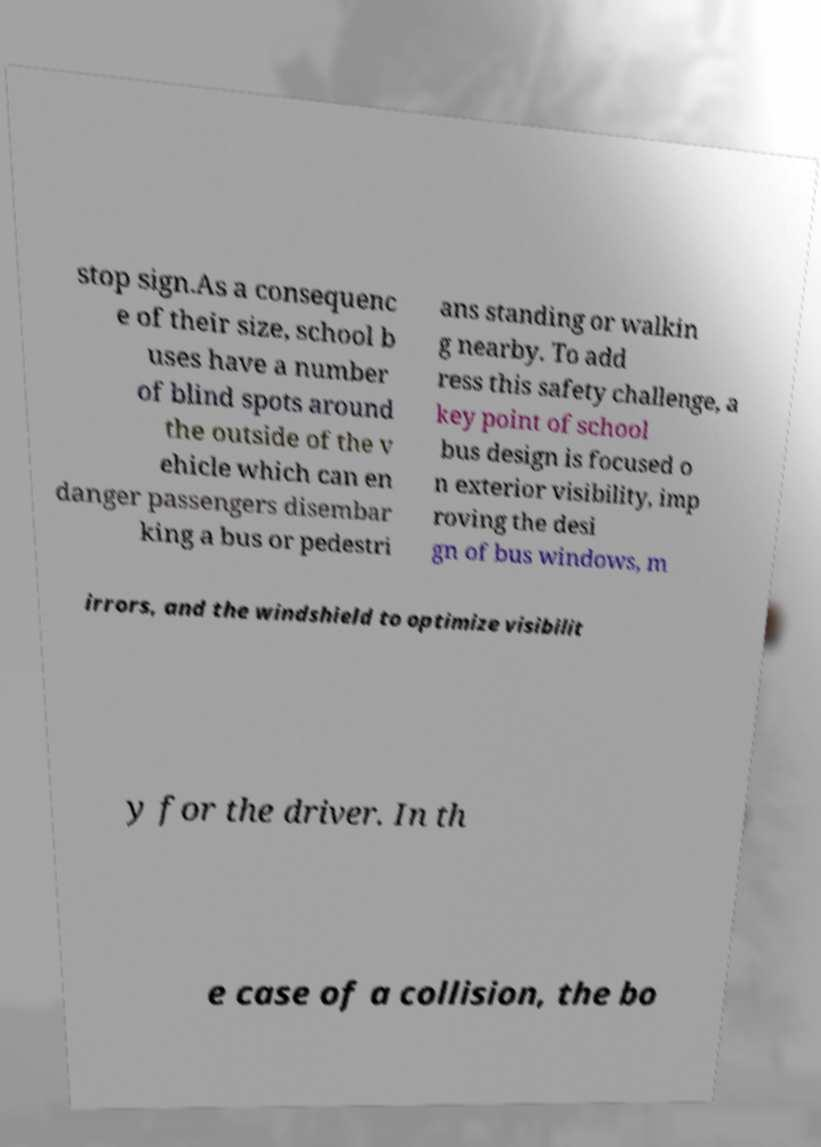I need the written content from this picture converted into text. Can you do that? stop sign.As a consequenc e of their size, school b uses have a number of blind spots around the outside of the v ehicle which can en danger passengers disembar king a bus or pedestri ans standing or walkin g nearby. To add ress this safety challenge, a key point of school bus design is focused o n exterior visibility, imp roving the desi gn of bus windows, m irrors, and the windshield to optimize visibilit y for the driver. In th e case of a collision, the bo 